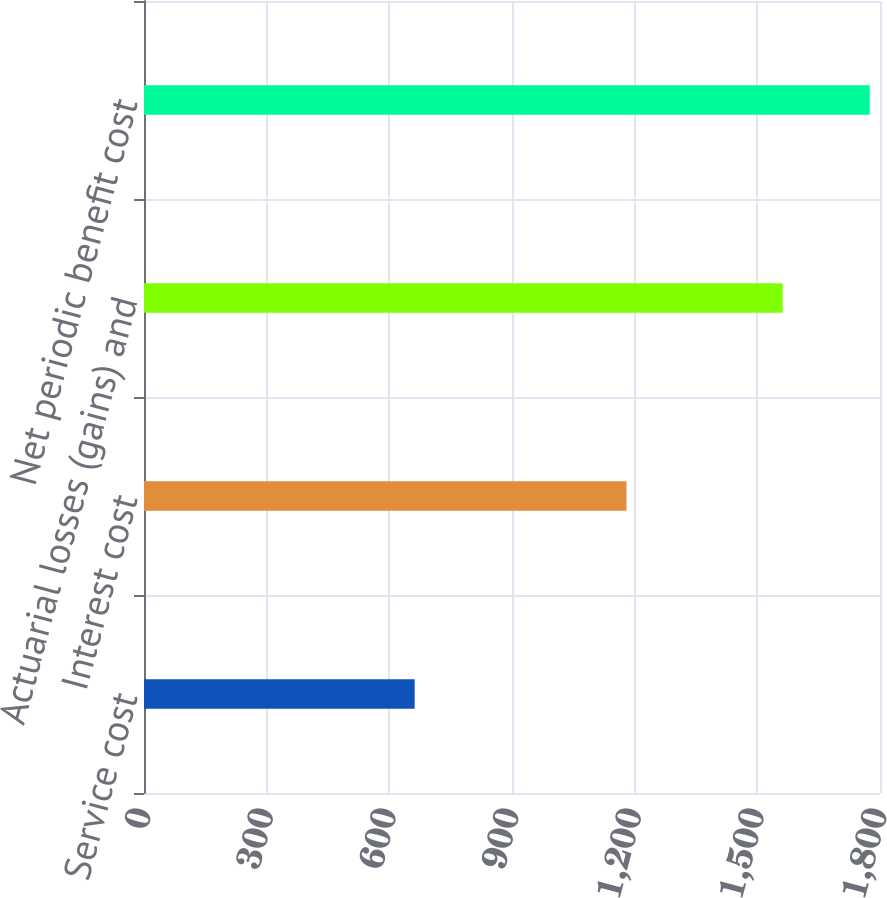Convert chart. <chart><loc_0><loc_0><loc_500><loc_500><bar_chart><fcel>Service cost<fcel>Interest cost<fcel>Actuarial losses (gains) and<fcel>Net periodic benefit cost<nl><fcel>662<fcel>1180<fcel>1562<fcel>1775<nl></chart> 